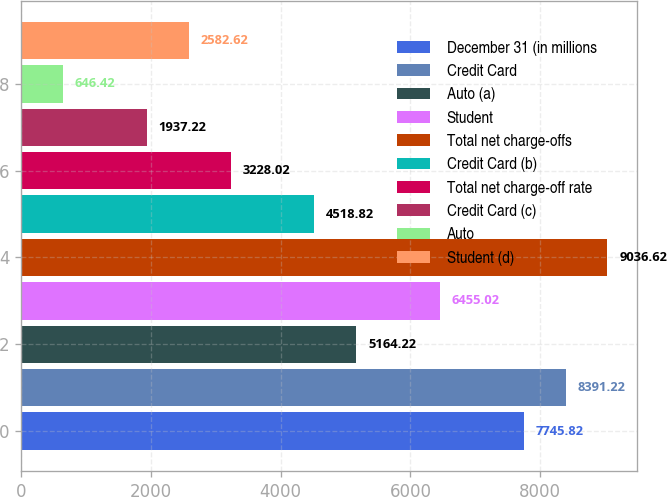Convert chart to OTSL. <chart><loc_0><loc_0><loc_500><loc_500><bar_chart><fcel>December 31 (in millions<fcel>Credit Card<fcel>Auto (a)<fcel>Student<fcel>Total net charge-offs<fcel>Credit Card (b)<fcel>Total net charge-off rate<fcel>Credit Card (c)<fcel>Auto<fcel>Student (d)<nl><fcel>7745.82<fcel>8391.22<fcel>5164.22<fcel>6455.02<fcel>9036.62<fcel>4518.82<fcel>3228.02<fcel>1937.22<fcel>646.42<fcel>2582.62<nl></chart> 